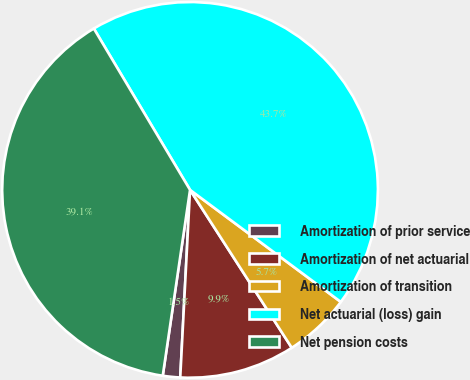Convert chart to OTSL. <chart><loc_0><loc_0><loc_500><loc_500><pie_chart><fcel>Amortization of prior service<fcel>Amortization of net actuarial<fcel>Amortization of transition<fcel>Net actuarial (loss) gain<fcel>Net pension costs<nl><fcel>1.49%<fcel>9.94%<fcel>5.72%<fcel>43.73%<fcel>39.12%<nl></chart> 